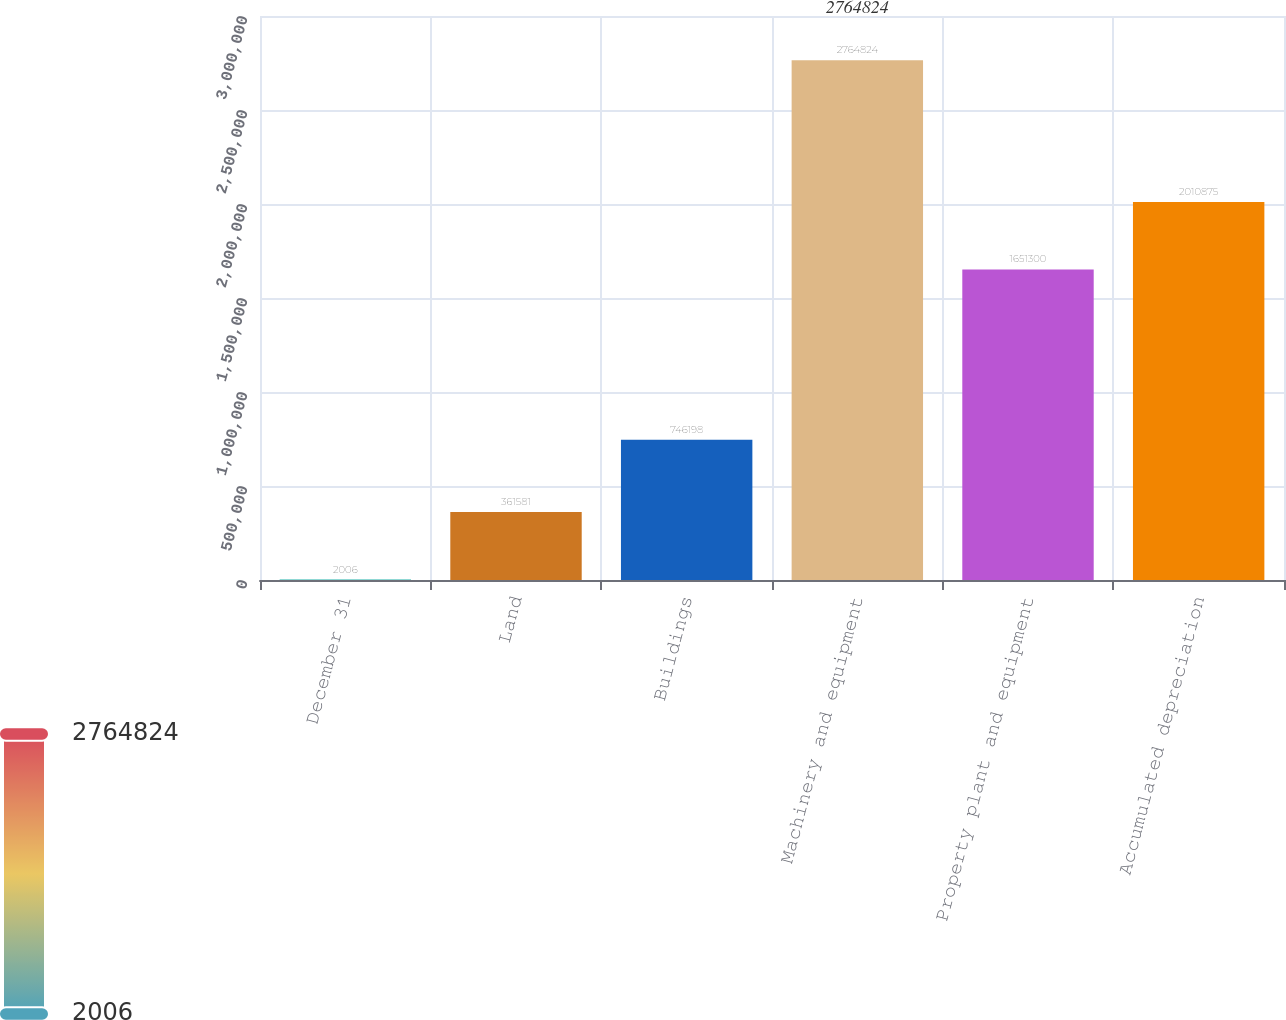Convert chart to OTSL. <chart><loc_0><loc_0><loc_500><loc_500><bar_chart><fcel>December 31<fcel>Land<fcel>Buildings<fcel>Machinery and equipment<fcel>Property plant and equipment<fcel>Accumulated depreciation<nl><fcel>2006<fcel>361581<fcel>746198<fcel>2.76482e+06<fcel>1.6513e+06<fcel>2.01088e+06<nl></chart> 